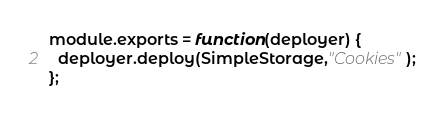<code> <loc_0><loc_0><loc_500><loc_500><_JavaScript_>
module.exports = function(deployer) {
  deployer.deploy(SimpleStorage,"Cookies");
};
</code> 